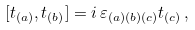<formula> <loc_0><loc_0><loc_500><loc_500>[ { t } _ { ( a ) } , { t } _ { ( b ) } ] = i \, \varepsilon _ { ( a ) ( b ) ( c ) } { t } _ { ( c ) } \, ,</formula> 